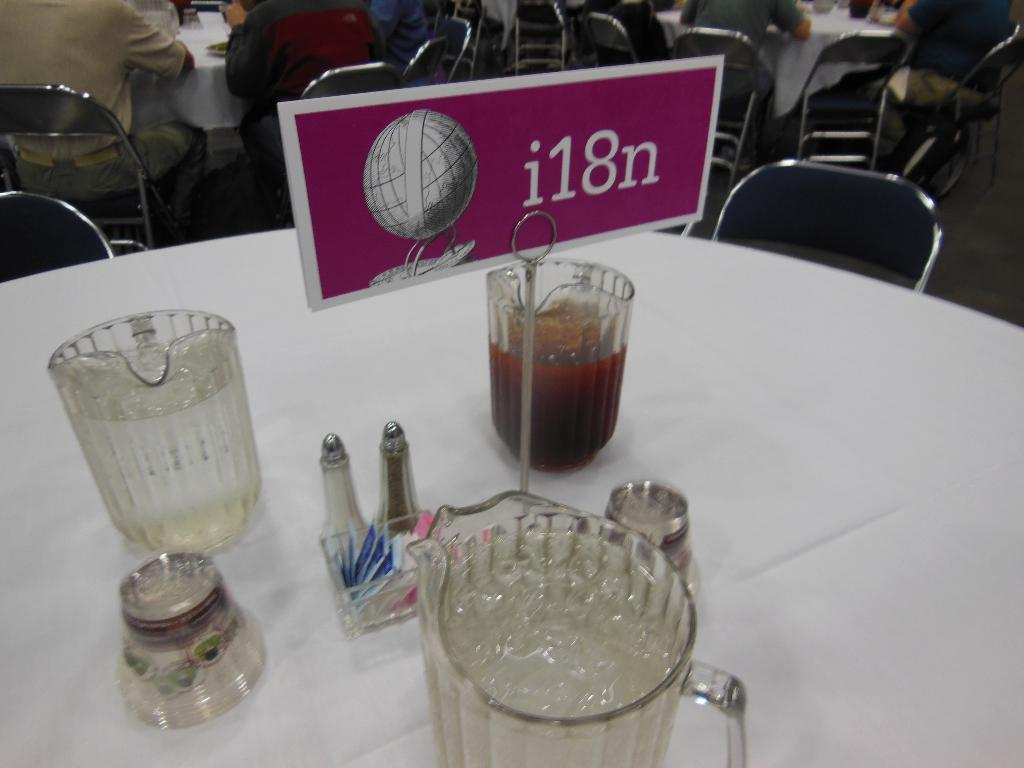<image>
Create a compact narrative representing the image presented. a conference table with the sign for i18n on it 